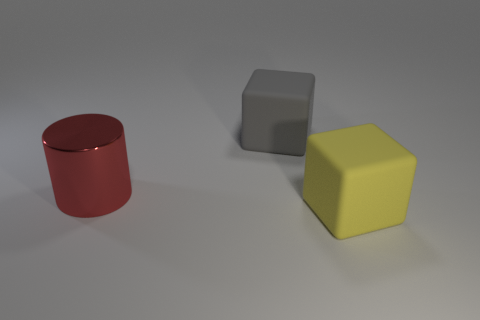Are there any other things that are the same material as the cylinder?
Provide a succinct answer. No. How many things are big matte blocks that are right of the gray block or rubber blocks that are in front of the large red metallic cylinder?
Ensure brevity in your answer.  1. Are there fewer metal objects that are on the left side of the red cylinder than gray matte blocks that are on the right side of the large yellow rubber thing?
Provide a short and direct response. No. Is the yellow object made of the same material as the large gray thing?
Offer a very short reply. Yes. There is a thing that is both on the right side of the large red metallic cylinder and in front of the gray object; how big is it?
Make the answer very short. Large. The gray rubber object that is the same size as the red metal cylinder is what shape?
Offer a very short reply. Cube. What is the material of the block on the right side of the matte object on the left side of the big matte object that is on the right side of the gray matte block?
Offer a terse response. Rubber. Do the large rubber thing that is in front of the red metal object and the rubber thing that is behind the big yellow block have the same shape?
Your answer should be compact. Yes. How many other objects are the same material as the gray object?
Your answer should be very brief. 1. Is the material of the large thing that is left of the gray matte block the same as the block in front of the metal object?
Your response must be concise. No. 